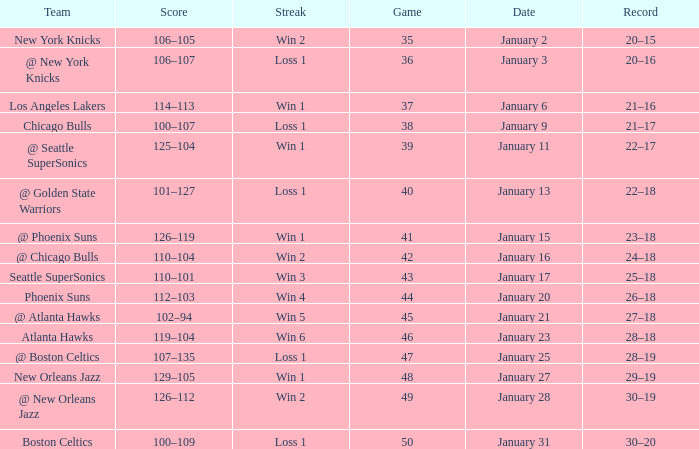What Game had a Score of 129–105? 48.0. I'm looking to parse the entire table for insights. Could you assist me with that? {'header': ['Team', 'Score', 'Streak', 'Game', 'Date', 'Record'], 'rows': [['New York Knicks', '106–105', 'Win 2', '35', 'January 2', '20–15'], ['@ New York Knicks', '106–107', 'Loss 1', '36', 'January 3', '20–16'], ['Los Angeles Lakers', '114–113', 'Win 1', '37', 'January 6', '21–16'], ['Chicago Bulls', '100–107', 'Loss 1', '38', 'January 9', '21–17'], ['@ Seattle SuperSonics', '125–104', 'Win 1', '39', 'January 11', '22–17'], ['@ Golden State Warriors', '101–127', 'Loss 1', '40', 'January 13', '22–18'], ['@ Phoenix Suns', '126–119', 'Win 1', '41', 'January 15', '23–18'], ['@ Chicago Bulls', '110–104', 'Win 2', '42', 'January 16', '24–18'], ['Seattle SuperSonics', '110–101', 'Win 3', '43', 'January 17', '25–18'], ['Phoenix Suns', '112–103', 'Win 4', '44', 'January 20', '26–18'], ['@ Atlanta Hawks', '102–94', 'Win 5', '45', 'January 21', '27–18'], ['Atlanta Hawks', '119–104', 'Win 6', '46', 'January 23', '28–18'], ['@ Boston Celtics', '107–135', 'Loss 1', '47', 'January 25', '28–19'], ['New Orleans Jazz', '129–105', 'Win 1', '48', 'January 27', '29–19'], ['@ New Orleans Jazz', '126–112', 'Win 2', '49', 'January 28', '30–19'], ['Boston Celtics', '100–109', 'Loss 1', '50', 'January 31', '30–20']]} 